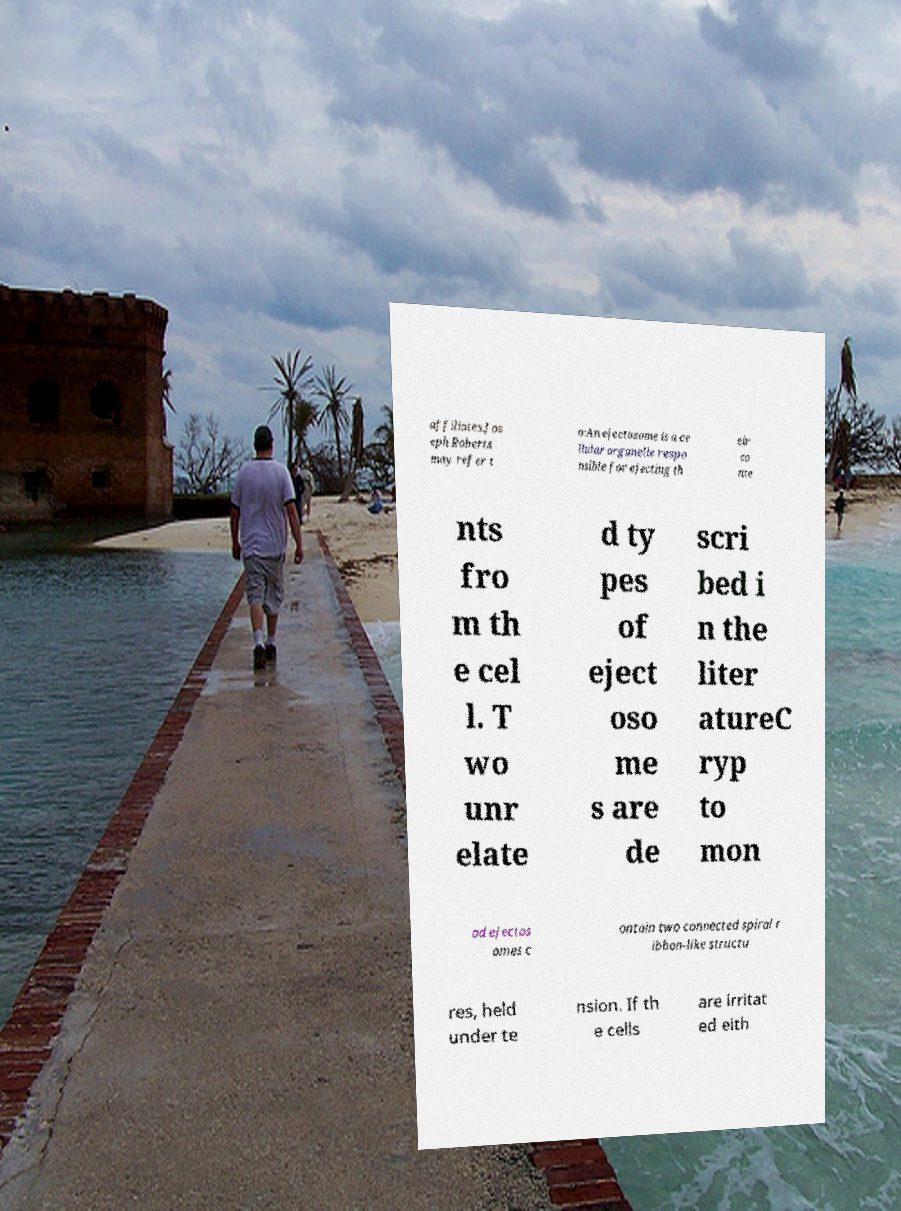Could you extract and type out the text from this image? affiliates.Jos eph Roberts may refer t o:An ejectosome is a ce llular organelle respo nsible for ejecting th eir co nte nts fro m th e cel l. T wo unr elate d ty pes of eject oso me s are de scri bed i n the liter atureC ryp to mon ad ejectos omes c ontain two connected spiral r ibbon-like structu res, held under te nsion. If th e cells are irritat ed eith 